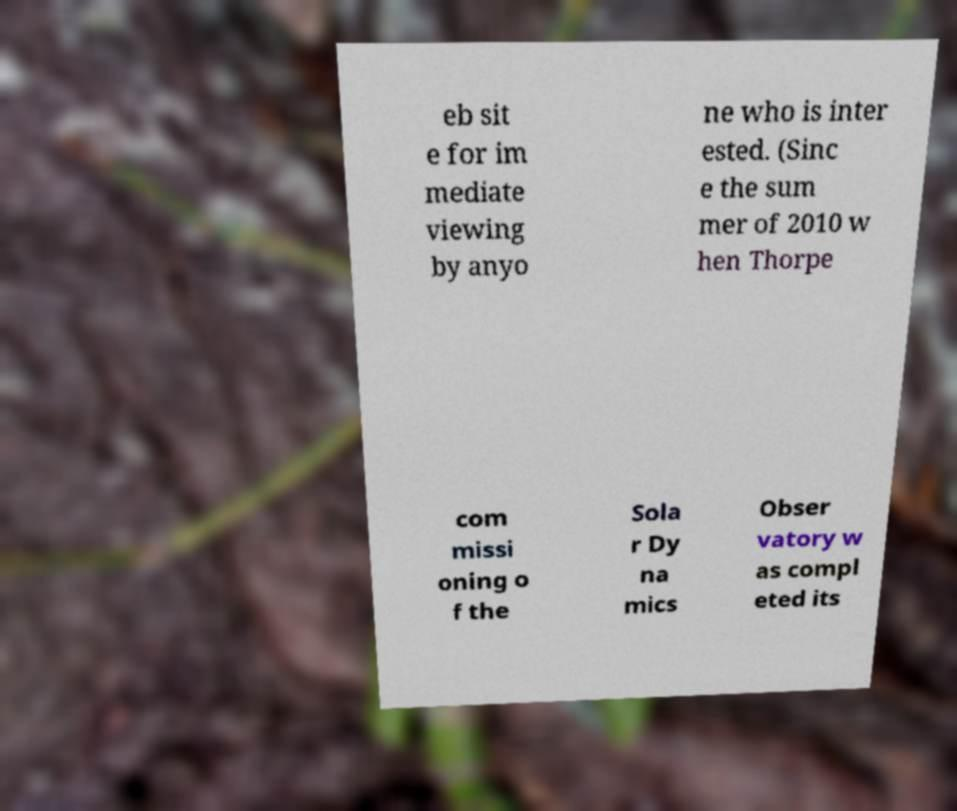Can you read and provide the text displayed in the image?This photo seems to have some interesting text. Can you extract and type it out for me? eb sit e for im mediate viewing by anyo ne who is inter ested. (Sinc e the sum mer of 2010 w hen Thorpe com missi oning o f the Sola r Dy na mics Obser vatory w as compl eted its 